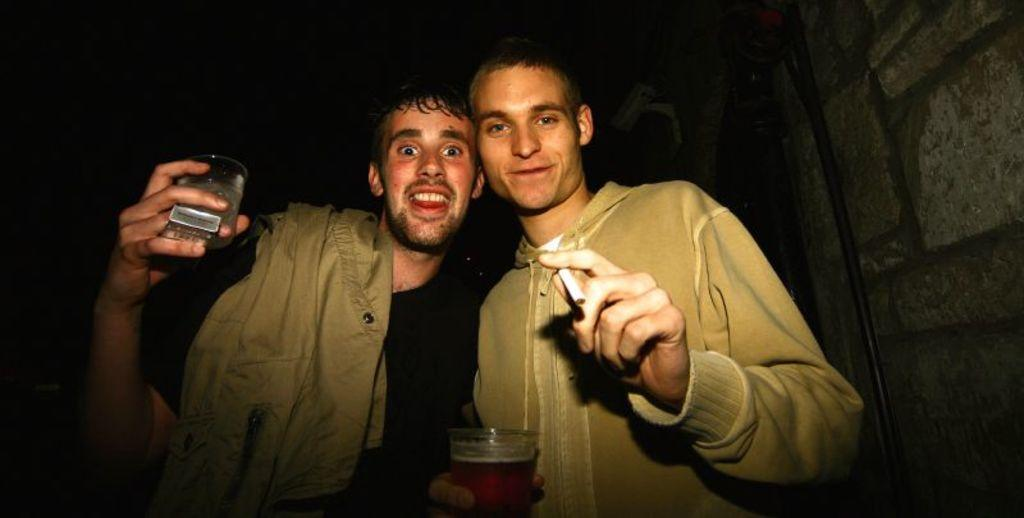How many people are in the image? There are two men in the image. What are the men holding in one hand? Each man is holding a glass in one hand. What are the men holding in their other hand? Each man is holding a cigarette in the other hand. What type of grape is being used as a prop in the image? There is no grape present in the image. How many groups of people can be seen in the image? There is only one group of people in the image, which consists of the two men. 